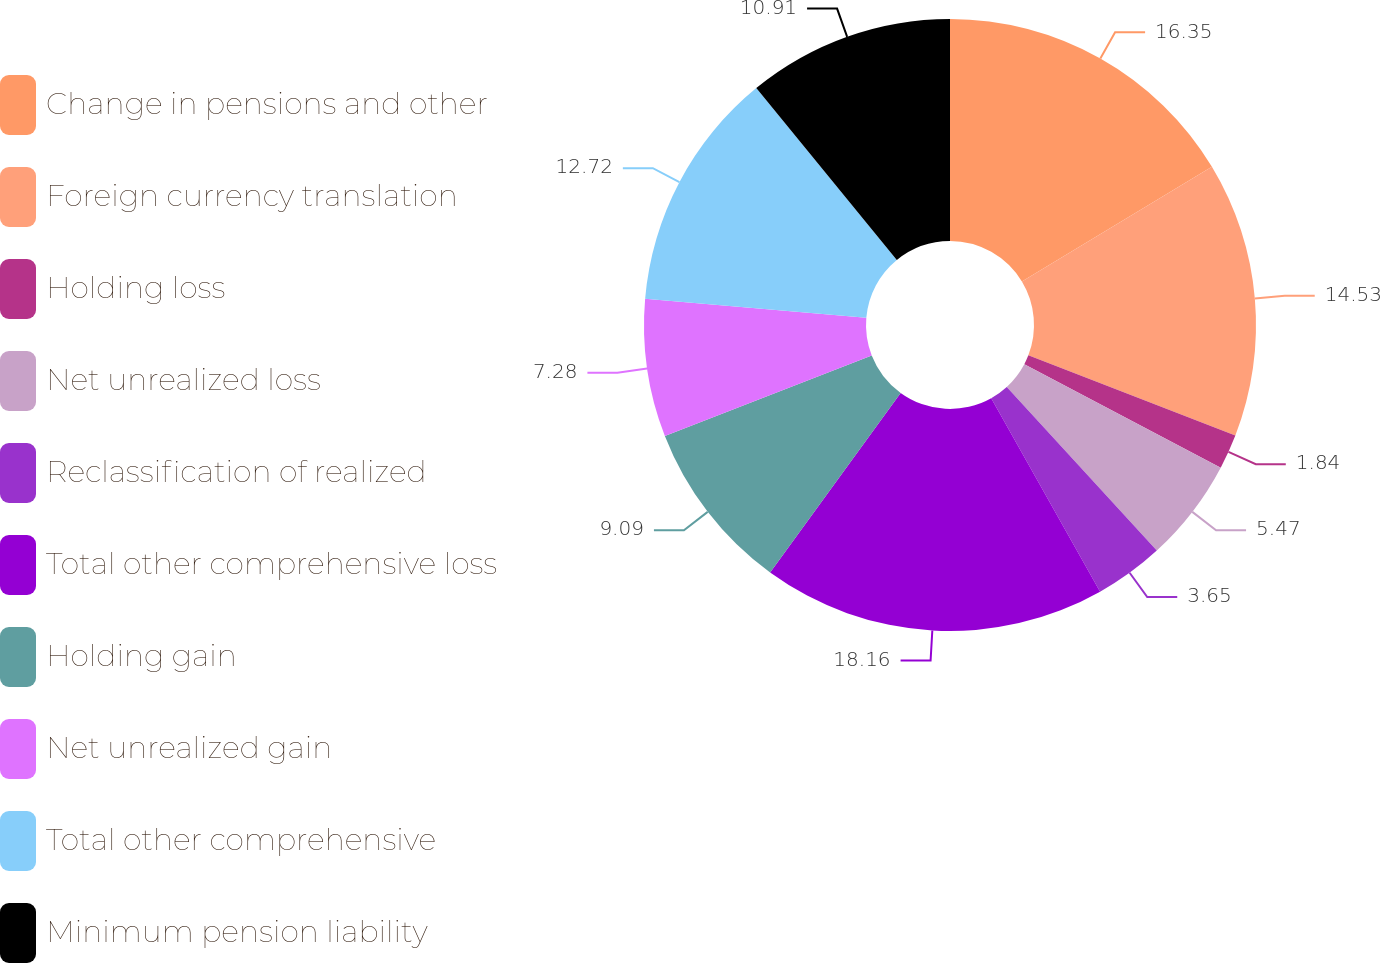<chart> <loc_0><loc_0><loc_500><loc_500><pie_chart><fcel>Change in pensions and other<fcel>Foreign currency translation<fcel>Holding loss<fcel>Net unrealized loss<fcel>Reclassification of realized<fcel>Total other comprehensive loss<fcel>Holding gain<fcel>Net unrealized gain<fcel>Total other comprehensive<fcel>Minimum pension liability<nl><fcel>16.35%<fcel>14.53%<fcel>1.84%<fcel>5.47%<fcel>3.65%<fcel>18.16%<fcel>9.09%<fcel>7.28%<fcel>12.72%<fcel>10.91%<nl></chart> 